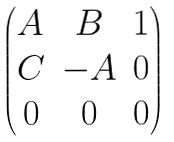<formula> <loc_0><loc_0><loc_500><loc_500>\begin{pmatrix} A & B & 1 \\ C & - A & 0 \\ 0 & 0 & 0 \end{pmatrix}</formula> 